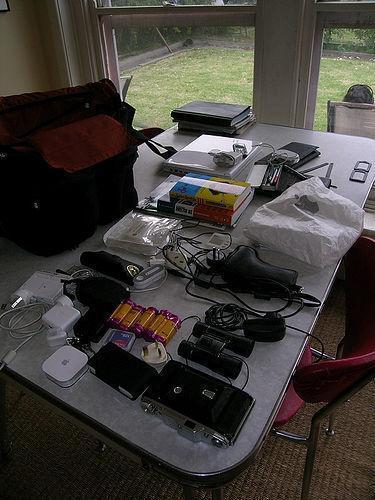How many glasses are on the table?
Give a very brief answer. 0. How many elephants are walking?
Give a very brief answer. 0. 